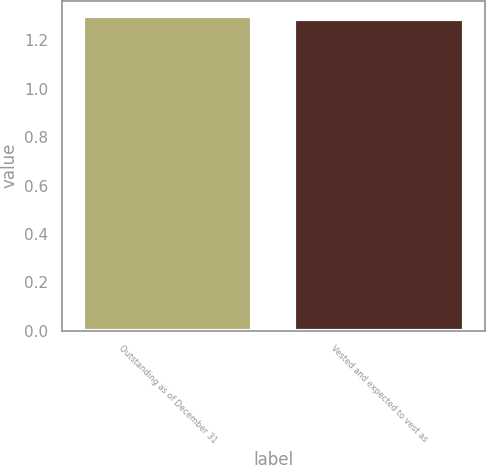<chart> <loc_0><loc_0><loc_500><loc_500><bar_chart><fcel>Outstanding as of December 31<fcel>Vested and expected to vest as<nl><fcel>1.3<fcel>1.29<nl></chart> 